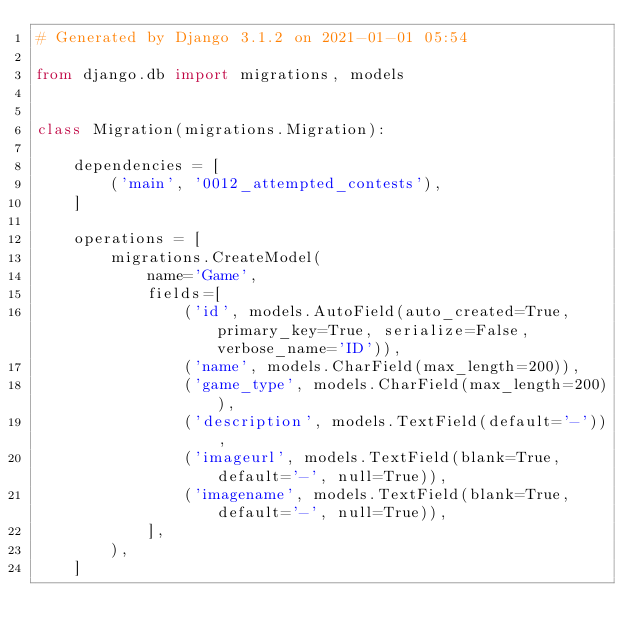<code> <loc_0><loc_0><loc_500><loc_500><_Python_># Generated by Django 3.1.2 on 2021-01-01 05:54

from django.db import migrations, models


class Migration(migrations.Migration):

    dependencies = [
        ('main', '0012_attempted_contests'),
    ]

    operations = [
        migrations.CreateModel(
            name='Game',
            fields=[
                ('id', models.AutoField(auto_created=True, primary_key=True, serialize=False, verbose_name='ID')),
                ('name', models.CharField(max_length=200)),
                ('game_type', models.CharField(max_length=200)),
                ('description', models.TextField(default='-')),
                ('imageurl', models.TextField(blank=True, default='-', null=True)),
                ('imagename', models.TextField(blank=True, default='-', null=True)),
            ],
        ),
    ]
</code> 